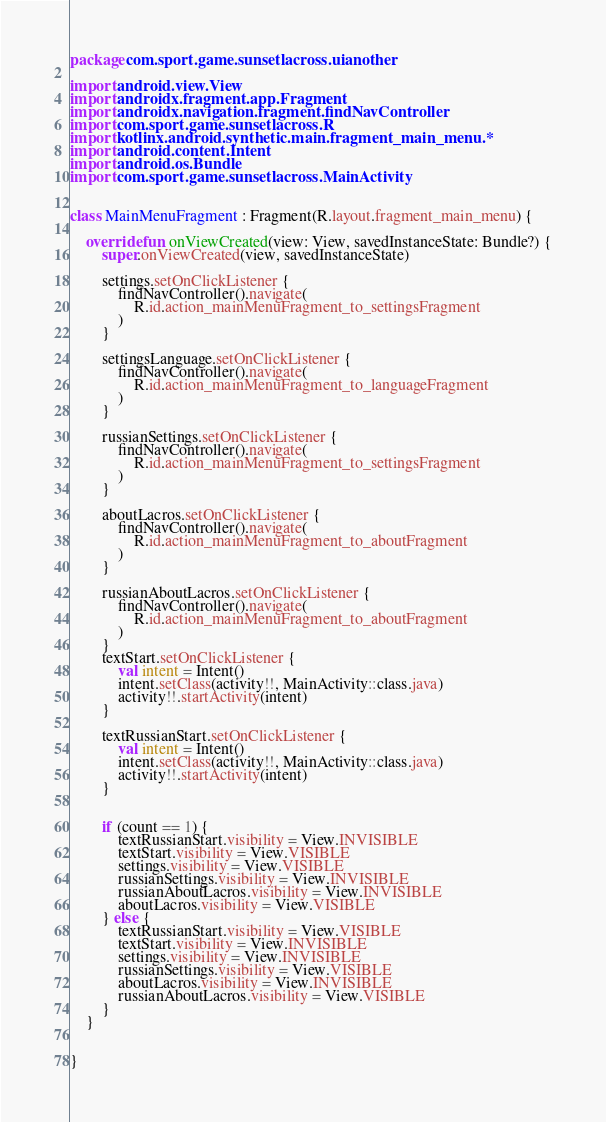Convert code to text. <code><loc_0><loc_0><loc_500><loc_500><_Kotlin_>package com.sport.game.sunsetlacross.uianother

import android.view.View
import androidx.fragment.app.Fragment
import androidx.navigation.fragment.findNavController
import com.sport.game.sunsetlacross.R
import kotlinx.android.synthetic.main.fragment_main_menu.*
import android.content.Intent
import android.os.Bundle
import com.sport.game.sunsetlacross.MainActivity


class MainMenuFragment : Fragment(R.layout.fragment_main_menu) {

    override fun onViewCreated(view: View, savedInstanceState: Bundle?) {
        super.onViewCreated(view, savedInstanceState)

        settings.setOnClickListener {
            findNavController().navigate(
                R.id.action_mainMenuFragment_to_settingsFragment
            )
        }

        settingsLanguage.setOnClickListener {
            findNavController().navigate(
                R.id.action_mainMenuFragment_to_languageFragment
            )
        }

        russianSettings.setOnClickListener {
            findNavController().navigate(
                R.id.action_mainMenuFragment_to_settingsFragment
            )
        }

        aboutLacros.setOnClickListener {
            findNavController().navigate(
                R.id.action_mainMenuFragment_to_aboutFragment
            )
        }

        russianAboutLacros.setOnClickListener {
            findNavController().navigate(
                R.id.action_mainMenuFragment_to_aboutFragment
            )
        }
        textStart.setOnClickListener {
            val intent = Intent()
            intent.setClass(activity!!, MainActivity::class.java)
            activity!!.startActivity(intent)
        }

        textRussianStart.setOnClickListener {
            val intent = Intent()
            intent.setClass(activity!!, MainActivity::class.java)
            activity!!.startActivity(intent)
        }


        if (count == 1) {
            textRussianStart.visibility = View.INVISIBLE
            textStart.visibility = View.VISIBLE
            settings.visibility = View.VISIBLE
            russianSettings.visibility = View.INVISIBLE
            russianAboutLacros.visibility = View.INVISIBLE
            aboutLacros.visibility = View.VISIBLE
        } else {
            textRussianStart.visibility = View.VISIBLE
            textStart.visibility = View.INVISIBLE
            settings.visibility = View.INVISIBLE
            russianSettings.visibility = View.VISIBLE
            aboutLacros.visibility = View.INVISIBLE
            russianAboutLacros.visibility = View.VISIBLE
        }
    }


}</code> 